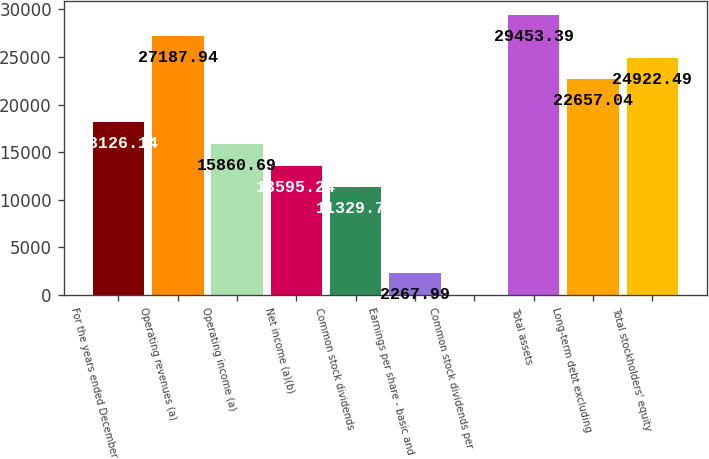<chart> <loc_0><loc_0><loc_500><loc_500><bar_chart><fcel>For the years ended December<fcel>Operating revenues (a)<fcel>Operating income (a)<fcel>Net income (a)(b)<fcel>Common stock dividends<fcel>Earnings per share - basic and<fcel>Common stock dividends per<fcel>Total assets<fcel>Long-term debt excluding<fcel>Total stockholders' equity<nl><fcel>18126.1<fcel>27187.9<fcel>15860.7<fcel>13595.2<fcel>11329.8<fcel>2267.99<fcel>2.54<fcel>29453.4<fcel>22657<fcel>24922.5<nl></chart> 